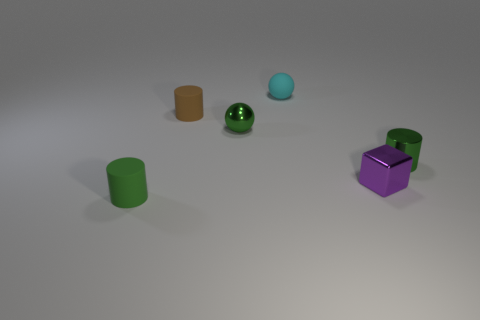Subtract all gray spheres. Subtract all brown cylinders. How many spheres are left? 2 Add 1 tiny cyan rubber balls. How many objects exist? 7 Subtract all balls. How many objects are left? 4 Subtract 0 brown cubes. How many objects are left? 6 Subtract all small metallic cylinders. Subtract all metal cylinders. How many objects are left? 4 Add 3 small green matte things. How many small green matte things are left? 4 Add 5 tiny brown objects. How many tiny brown objects exist? 6 